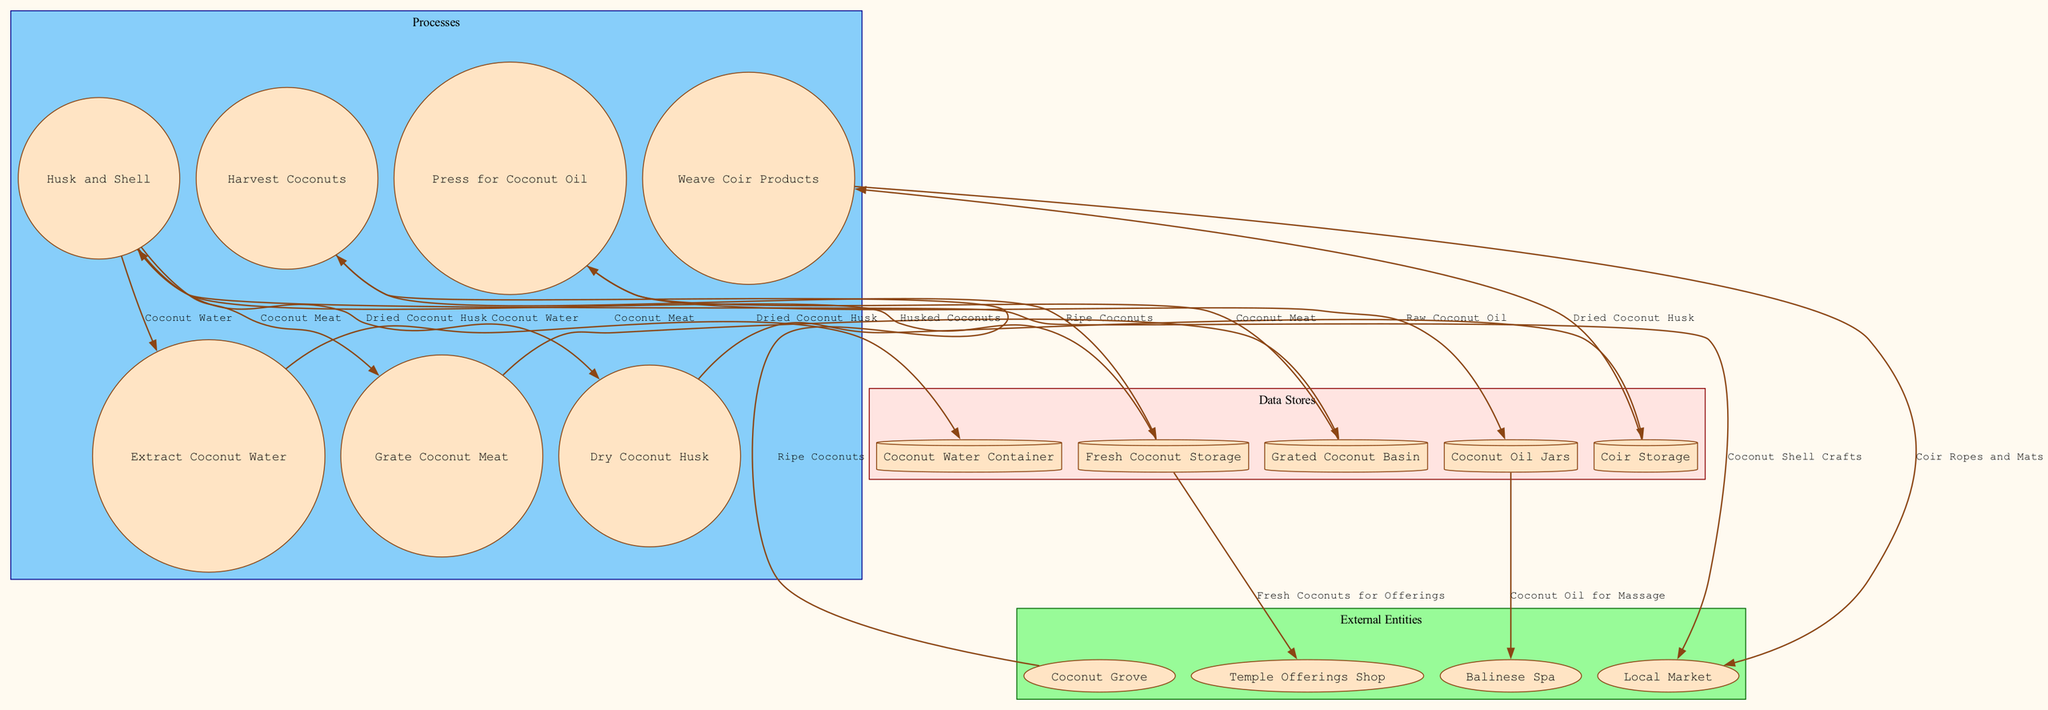What are the external entities in the diagram? The diagram includes four external entities: Coconut Grove, Local Market, Temple Offerings Shop, and Balinese Spa, all of which are depicted in the external entities section.
Answer: Coconut Grove, Local Market, Temple Offerings Shop, Balinese Spa How many processes are shown in the diagram? Counting the processes in the processes section, there are six distinct processes: Harvest Coconuts, Husk and Shell, Extract Coconut Water, Grate Coconut Meat, Press for Coconut Oil, Dry Coconut Husk, and Weave Coir Products.
Answer: Six What data flows from the Grated Coconut Basin? From the Grated Coconut Basin, the data flows toward two processes: Press for Coconut Oil and it can also flow towards another data store, called Coconut Oil Jars, leading to the final product.
Answer: Coconut Meat Which data store contains Coconut Oil? The diagram indicates that Coconut Oil is stored in the Coconut Oil Jars, which is a data store represented in the data stores section of the diagram.
Answer: Coconut Oil Jars What is the output of the "Weave Coir Products" process? Following the Weave Coir Products process, the output is directed to the Local Market as indicated by the data flow arrow, which signifies the final product reaching its destination.
Answer: Coir Ropes and Mats What process follows after "Extract Coconut Water"? According to the diagram, the process that follows Extract Coconut Water is Grate Coconut Meat, which is the next step in the coconut product manufacturing sequence.
Answer: Grate Coconut Meat What item is sent to the Temple Offerings Shop? The diagram shows that Fresh Coconuts, after being stored, are directed to the Temple Offerings Shop, designated to be offered at temples.
Answer: Fresh Coconuts for Offerings How many distinct data stores are represented? By examining the data stores section, there are five distinct data stores listed: Fresh Coconut Storage, Coconut Water Container, Grated Coconut Basin, Coconut Oil Jars, and Coir Storage.
Answer: Five What is produced from pressing for Coconut Oil? The process Press for Coconut Oil produces Raw Coconut Oil as indicated in the data flow leading to the data store Coconut Oil Jars.
Answer: Raw Coconut Oil 